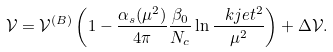<formula> <loc_0><loc_0><loc_500><loc_500>\mathcal { V } = \mathcal { V } ^ { ( B ) } \left ( 1 - \frac { \alpha _ { s } ( \mu ^ { 2 } ) } { 4 \pi } \frac { \beta _ { 0 } } { N _ { c } } \ln \frac { \ k j e t ^ { 2 } } { \mu ^ { 2 } } \right ) + \Delta \mathcal { V } .</formula> 